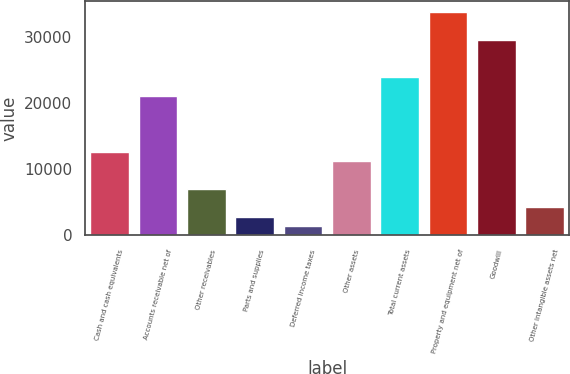Convert chart. <chart><loc_0><loc_0><loc_500><loc_500><bar_chart><fcel>Cash and cash equivalents<fcel>Accounts receivable net of<fcel>Other receivables<fcel>Parts and supplies<fcel>Deferred income taxes<fcel>Other assets<fcel>Total current assets<fcel>Property and equipment net of<fcel>Goodwill<fcel>Other intangible assets net<nl><fcel>12693.3<fcel>21151.5<fcel>7054.5<fcel>2825.4<fcel>1415.7<fcel>11283.6<fcel>23970.9<fcel>33838.8<fcel>29609.7<fcel>4235.1<nl></chart> 